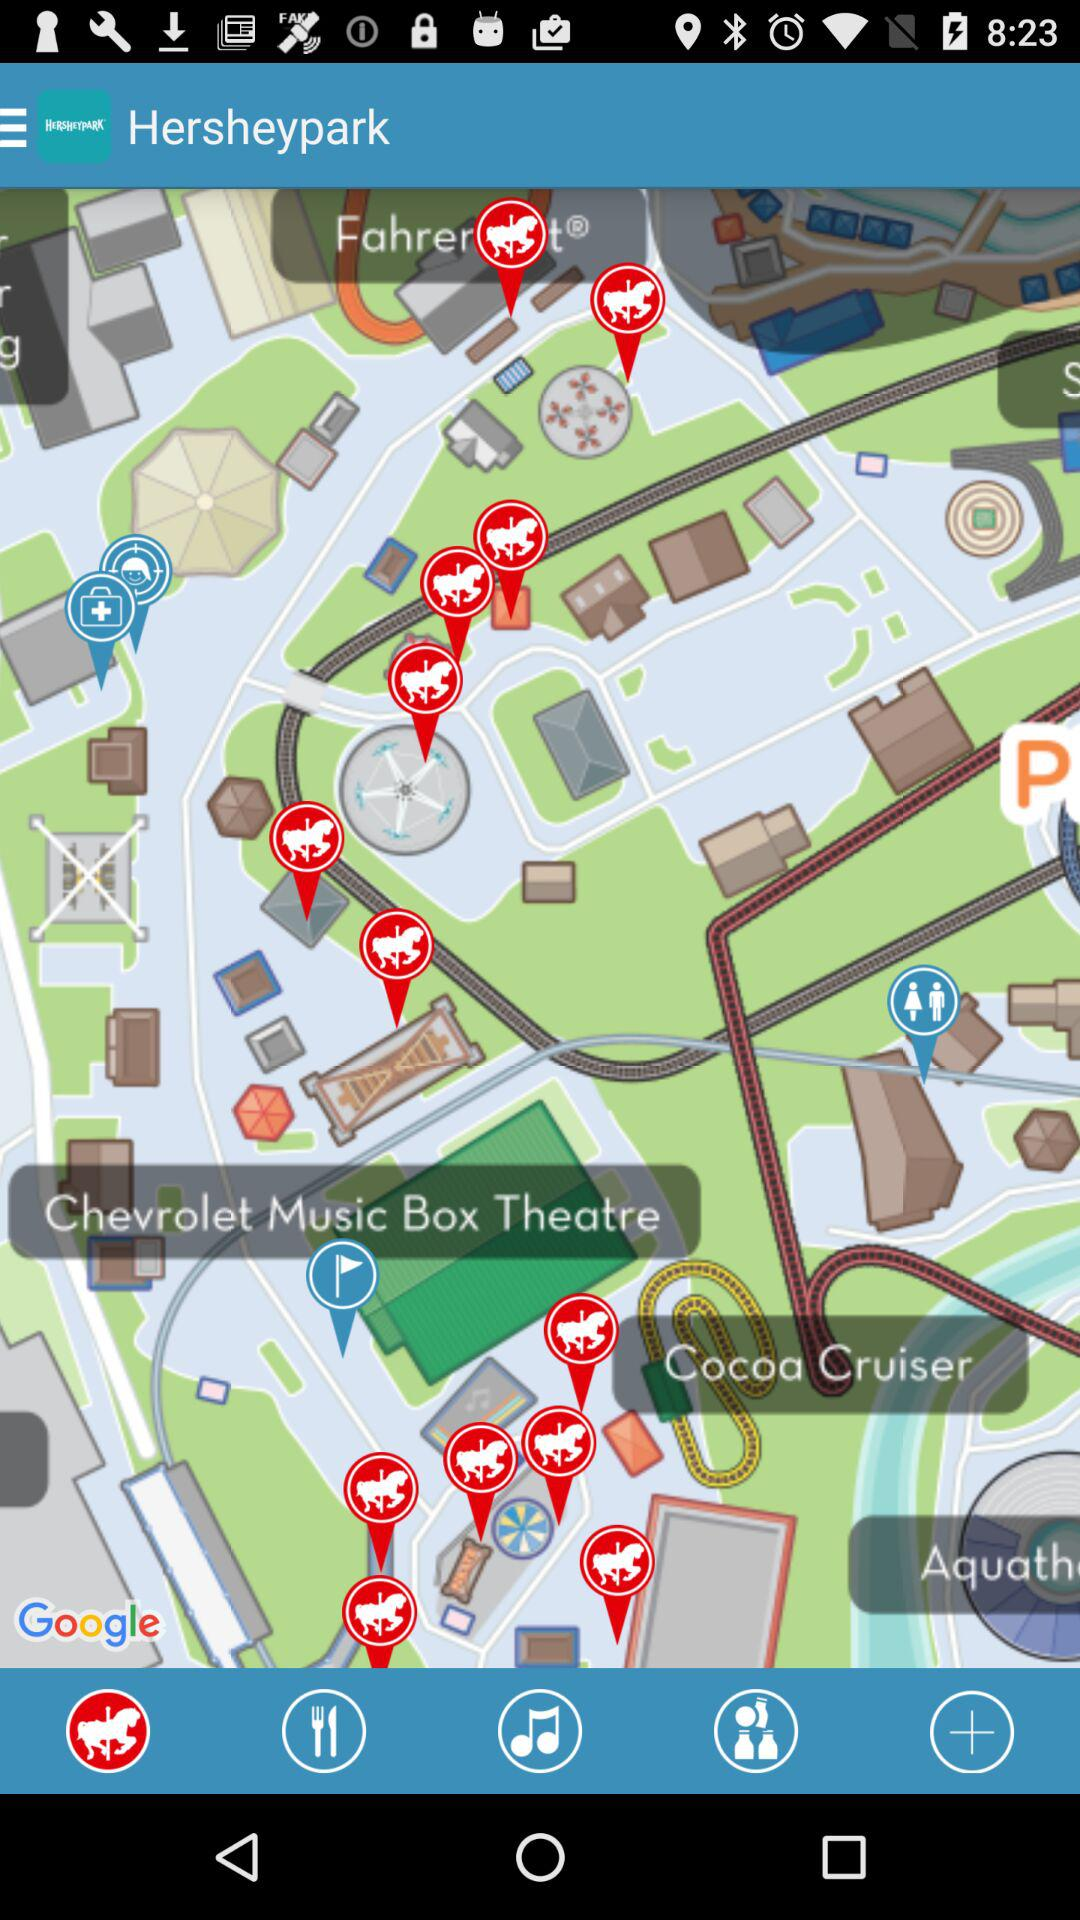What is the app name? The app name is "Hersheypark". 